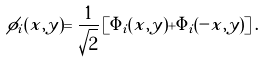Convert formula to latex. <formula><loc_0><loc_0><loc_500><loc_500>\phi _ { i } ( x , y ) = \frac { 1 } { \sqrt { 2 } } \left [ \Phi _ { i } ( x , y ) + \Phi _ { i } ( - x , y ) \right ] .</formula> 